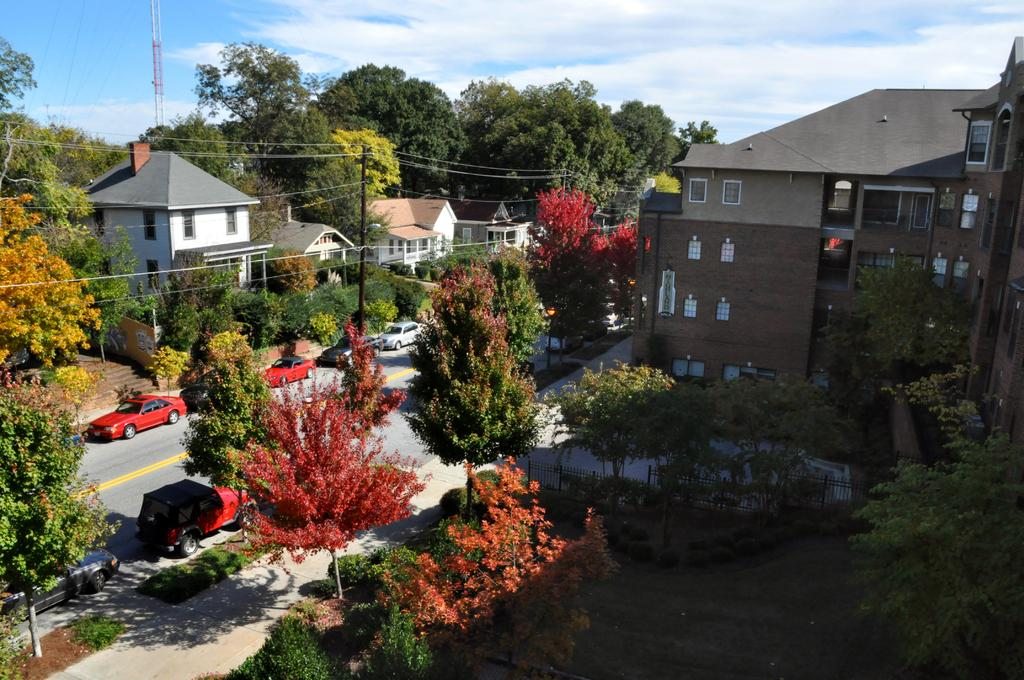What type of structures can be seen in the image? There are buildings in the image. What other natural elements are present in the image? There are trees in the image. What else can be seen in the image that is related to infrastructure? There are poles with wires in the image. What type of transportation is visible in the image? There are vehicles on the road in the image. What is visible in the sky at the top of the image? There are clouds visible in the sky at the top of the image. What degree does the partner have in the image? There is no partner present in the image, so it is not possible to determine their degree. What type of sun can be seen in the image? There is no sun visible in the image; only clouds are present in the sky. 